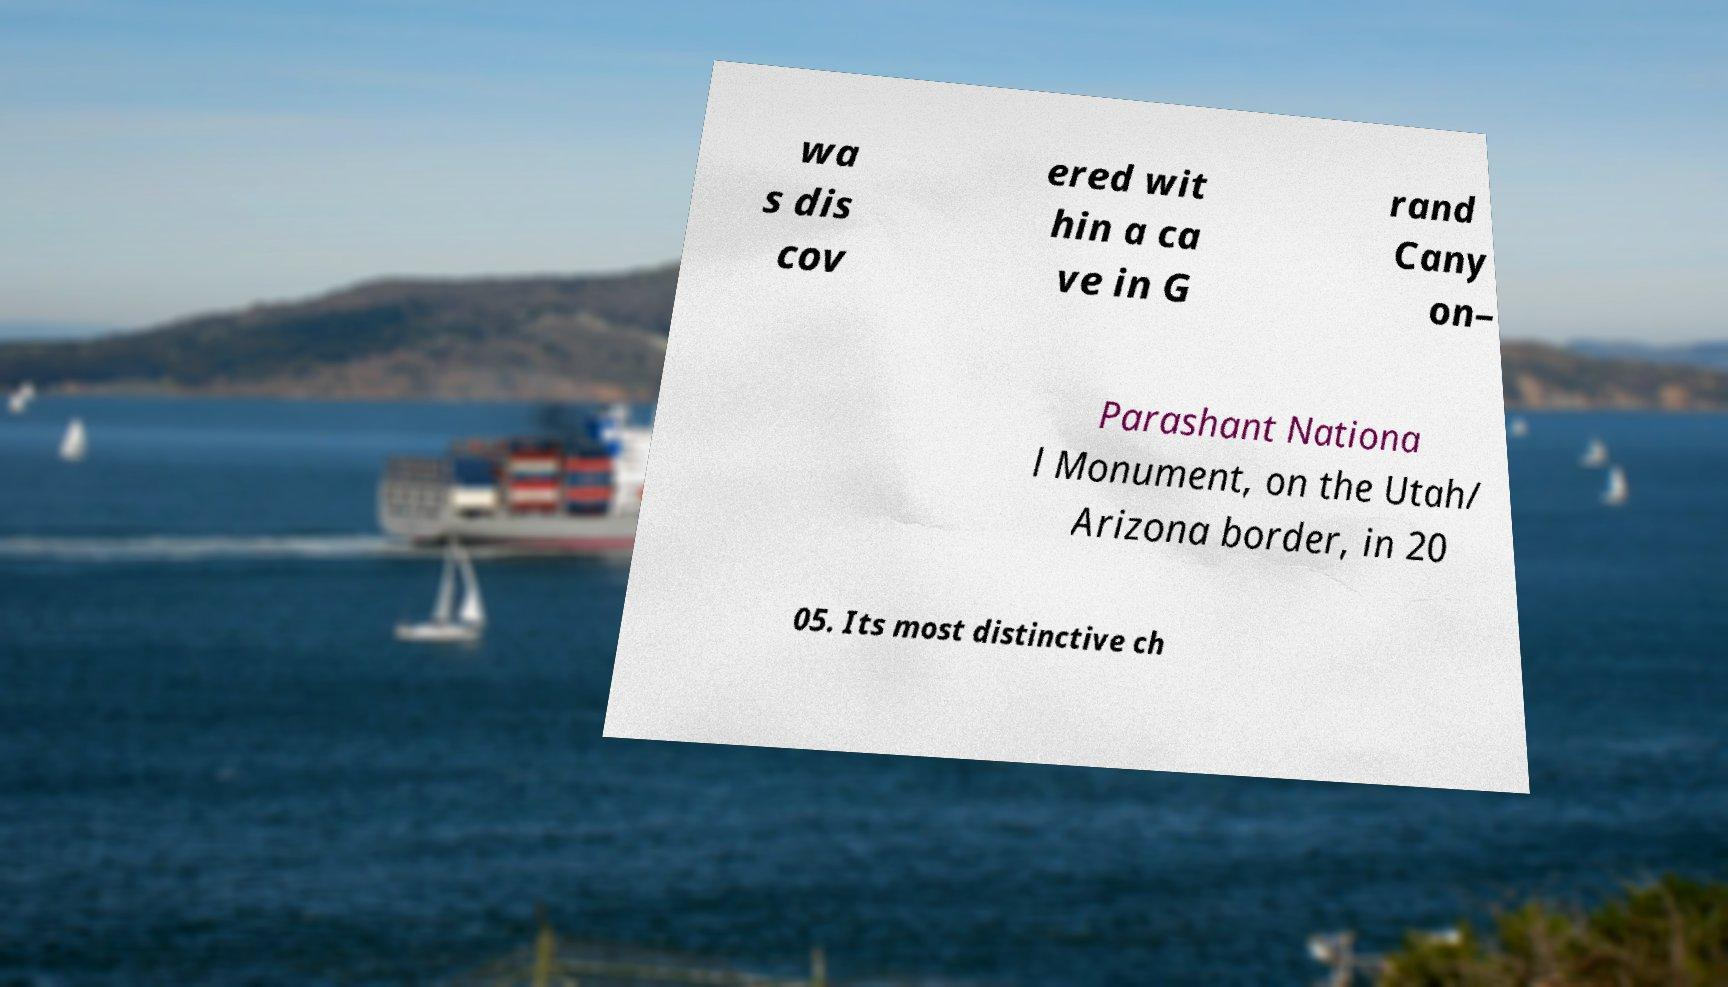For documentation purposes, I need the text within this image transcribed. Could you provide that? wa s dis cov ered wit hin a ca ve in G rand Cany on– Parashant Nationa l Monument, on the Utah/ Arizona border, in 20 05. Its most distinctive ch 